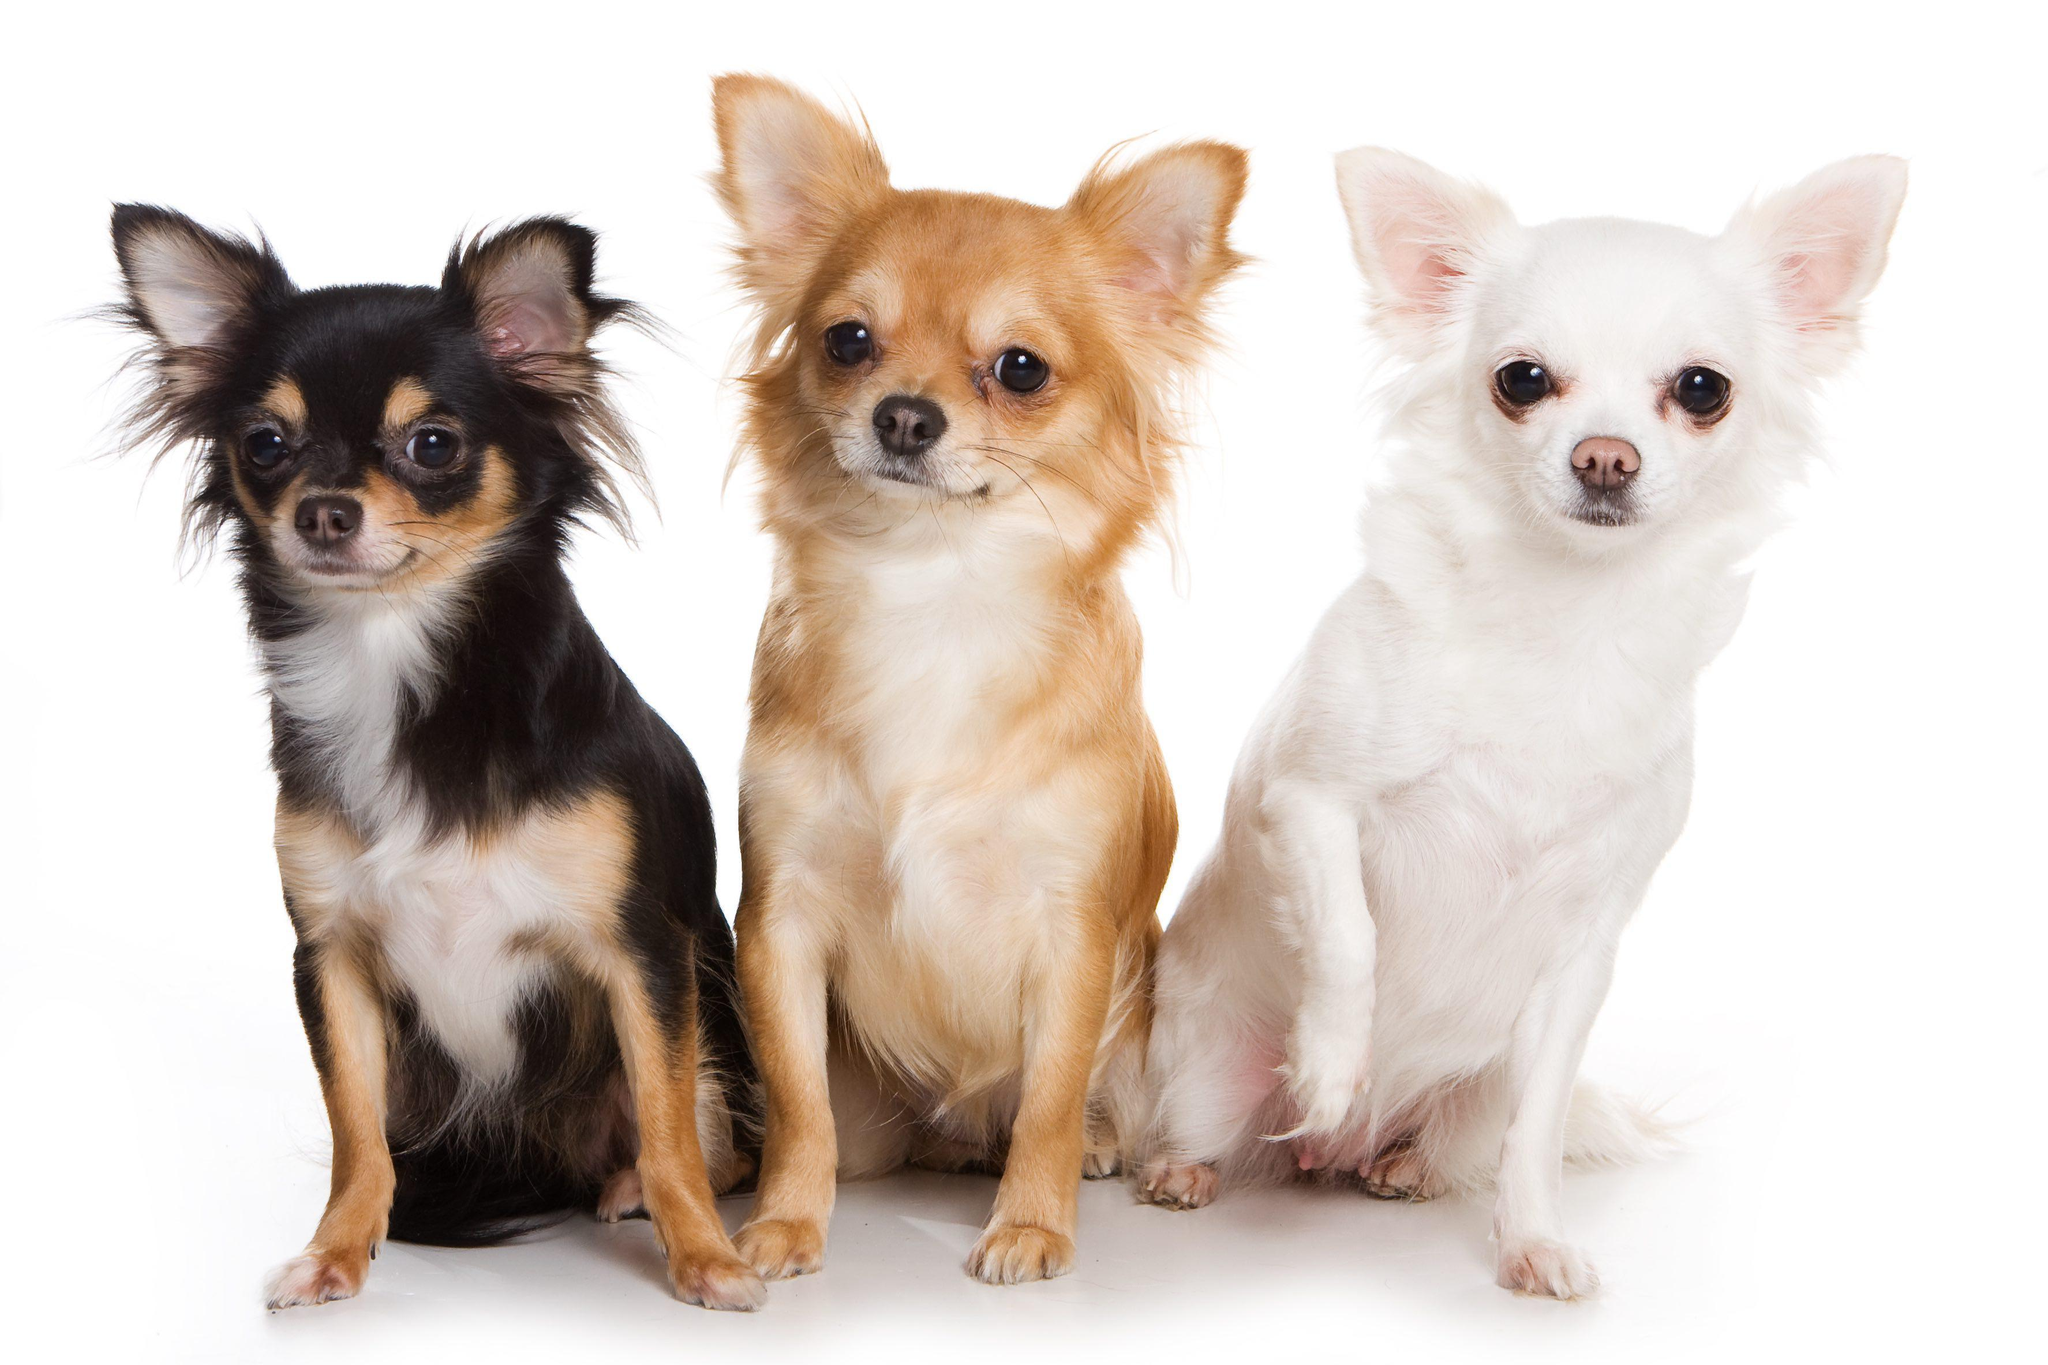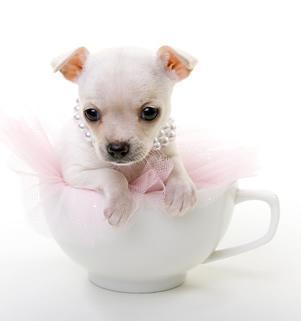The first image is the image on the left, the second image is the image on the right. Examine the images to the left and right. Is the description "The left image contains at least three chihuahuas sitting in a horizontal row." accurate? Answer yes or no. Yes. The first image is the image on the left, the second image is the image on the right. Considering the images on both sides, is "In one image, a very small dog is inside of a teacup" valid? Answer yes or no. Yes. 